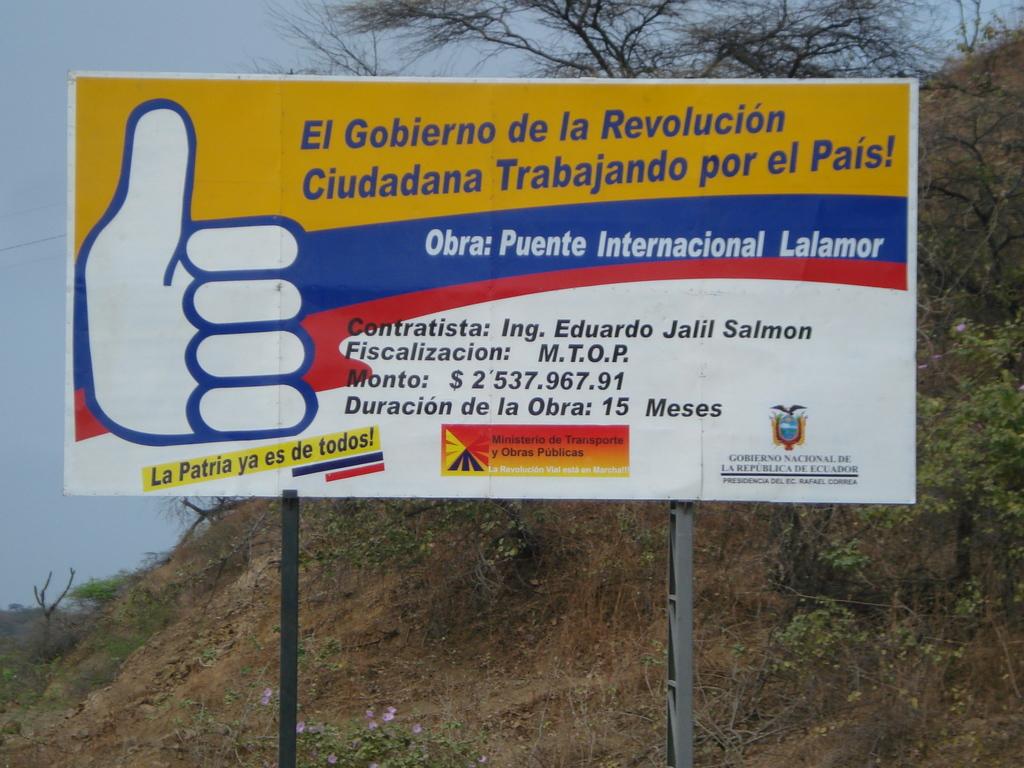Is the poster in english?
Make the answer very short. No. What is the amount of money shown on the sign?
Give a very brief answer. 2,537,967.91. 